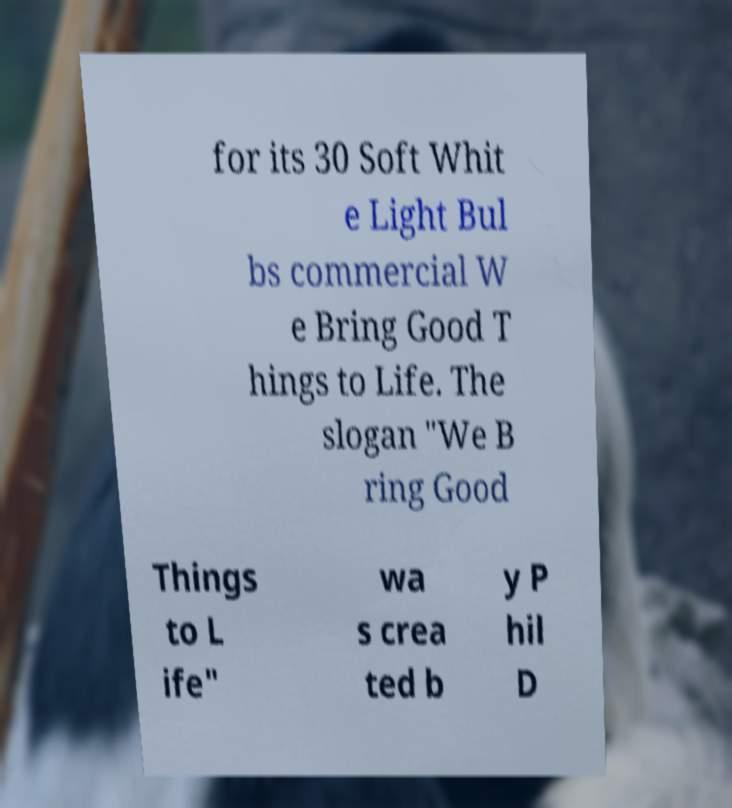What messages or text are displayed in this image? I need them in a readable, typed format. for its 30 Soft Whit e Light Bul bs commercial W e Bring Good T hings to Life. The slogan "We B ring Good Things to L ife" wa s crea ted b y P hil D 